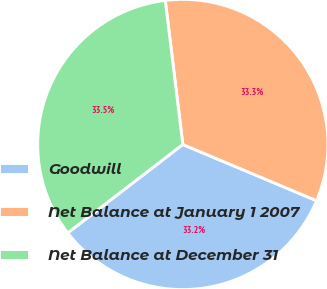Convert chart. <chart><loc_0><loc_0><loc_500><loc_500><pie_chart><fcel>Goodwill<fcel>Net Balance at January 1 2007<fcel>Net Balance at December 31<nl><fcel>33.24%<fcel>33.26%<fcel>33.5%<nl></chart> 